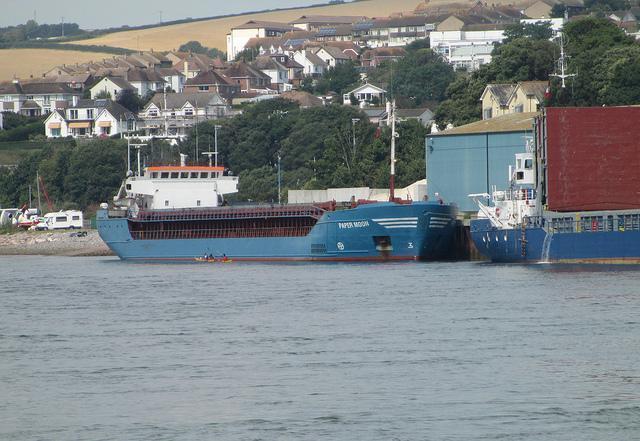What might live in this environment?
From the following set of four choices, select the accurate answer to respond to the question.
Options: Fish, birds, worms, cats. Fish. 